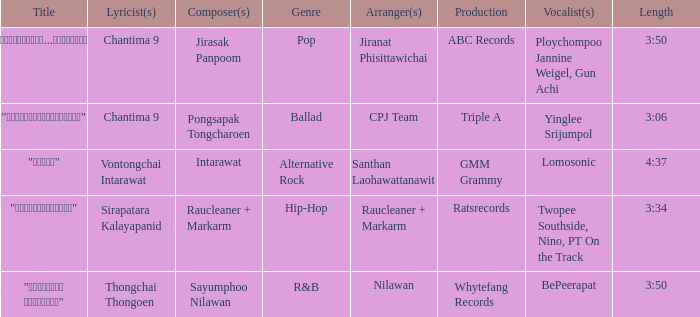Who was responsible for composing "ขอโทษ"? Intarawat. 